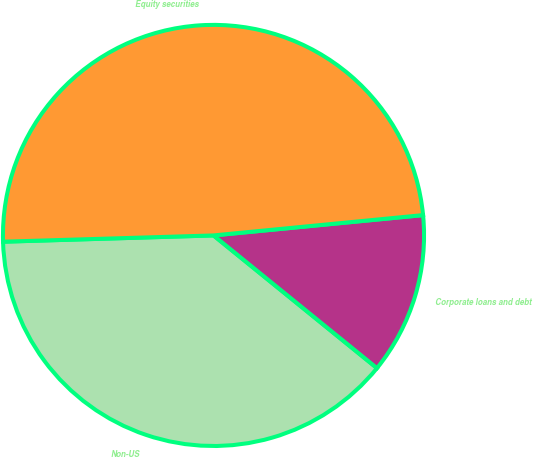Convert chart. <chart><loc_0><loc_0><loc_500><loc_500><pie_chart><fcel>Non-US<fcel>Corporate loans and debt<fcel>Equity securities<nl><fcel>38.67%<fcel>12.39%<fcel>48.93%<nl></chart> 